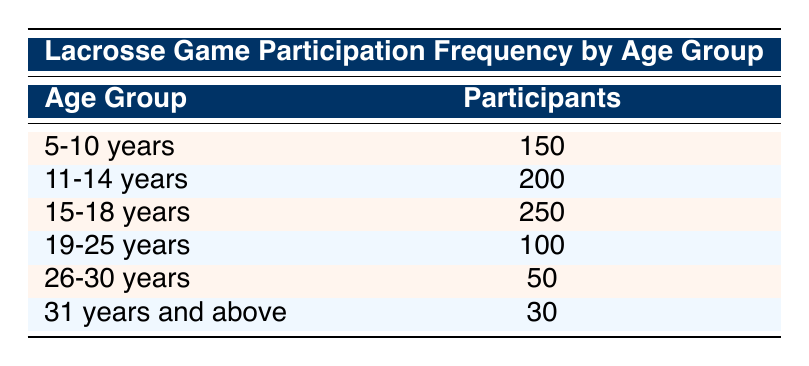What is the total number of participants aged 15-18 years? The table shows that the number of participants in the age group 15-18 years is listed as 250.
Answer: 250 How many participants are there in the age group 5-10 years? According to the table, the 5-10 years age group has 150 participants.
Answer: 150 Is the number of participants in the age group 19-25 years greater than those in the 26-30 years age group? The table shows 100 participants in the 19-25 years age group and 50 participants in the 26-30 years age group. Since 100 is greater than 50, the statement is true.
Answer: Yes What is the average number of participants across all age groups? To find the average, we first sum the participants: 150 + 200 + 250 + 100 + 50 + 30 = 780. There are 6 age groups, so we divide 780 by 6, which equals 130.
Answer: 130 Which age group has the least number of participants? By comparing the participants across all age groups in the table, we see that the 31 years and above group has the least number of participants, with 30.
Answer: 31 years and above What is the total number of participants from age groups 5-14 years? The relevant age groups are 5-10 years (150 participants) and 11-14 years (200 participants). Adding them gives us 150 + 200 = 350.
Answer: 350 Is the number of participants in the age group 15-18 years more than the combined number of participants in the age groups 19-30 years? The age group 15-18 years has 250 participants. The combined total for 19-25 years (100) and 26-30 years (50) is 150. Since 250 is more than 150, the statement is true.
Answer: Yes What percentage of total participants are aged 31 years and above? The total number of participants is 780. The participants in the 31 years and above group are 30. To find the percentage, we calculate (30 / 780) * 100 = approximately 3.85%.
Answer: Approximately 3.85% What is the difference in the number of participants between the age groups 11-14 years and 19-25 years? The 11-14 years group has 200 participants and the 19-25 years group has 100 participants. The difference is 200 - 100 = 100.
Answer: 100 